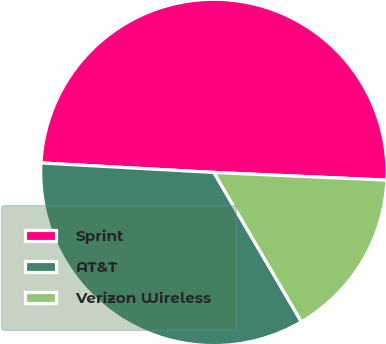Convert chart. <chart><loc_0><loc_0><loc_500><loc_500><pie_chart><fcel>Sprint<fcel>AT&T<fcel>Verizon Wireless<nl><fcel>49.84%<fcel>34.31%<fcel>15.85%<nl></chart> 